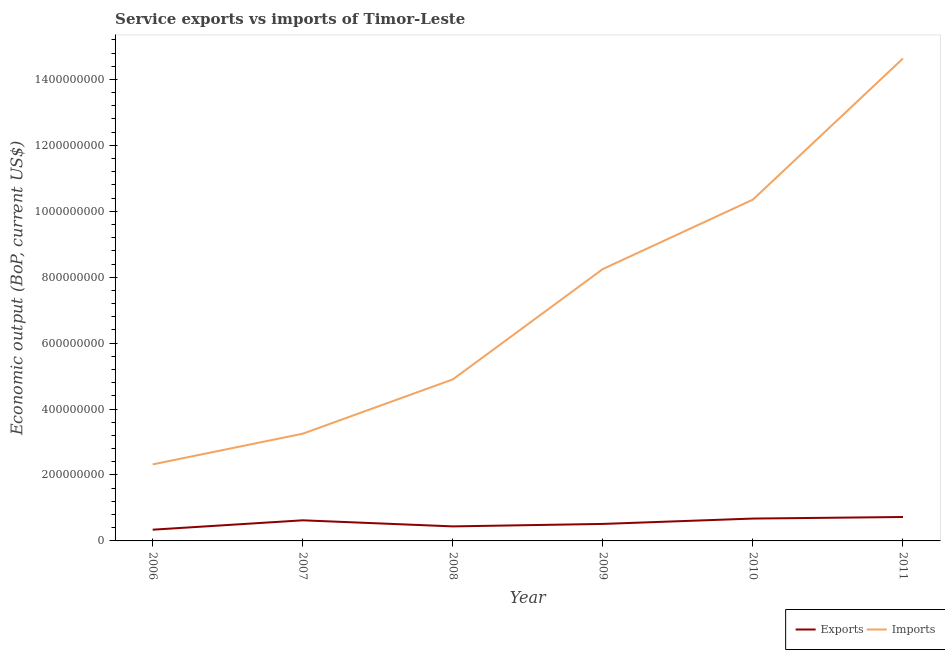How many different coloured lines are there?
Ensure brevity in your answer.  2. What is the amount of service imports in 2011?
Offer a very short reply. 1.46e+09. Across all years, what is the maximum amount of service imports?
Offer a very short reply. 1.46e+09. Across all years, what is the minimum amount of service imports?
Provide a short and direct response. 2.32e+08. In which year was the amount of service exports minimum?
Your answer should be very brief. 2006. What is the total amount of service imports in the graph?
Ensure brevity in your answer.  4.37e+09. What is the difference between the amount of service imports in 2006 and that in 2007?
Offer a very short reply. -9.31e+07. What is the difference between the amount of service exports in 2011 and the amount of service imports in 2009?
Keep it short and to the point. -7.52e+08. What is the average amount of service exports per year?
Your answer should be compact. 5.54e+07. In the year 2011, what is the difference between the amount of service exports and amount of service imports?
Keep it short and to the point. -1.39e+09. In how many years, is the amount of service imports greater than 920000000 US$?
Keep it short and to the point. 2. What is the ratio of the amount of service imports in 2007 to that in 2011?
Offer a very short reply. 0.22. Is the difference between the amount of service imports in 2006 and 2008 greater than the difference between the amount of service exports in 2006 and 2008?
Give a very brief answer. No. What is the difference between the highest and the second highest amount of service exports?
Offer a terse response. 4.77e+06. What is the difference between the highest and the lowest amount of service exports?
Provide a short and direct response. 3.85e+07. Is the amount of service imports strictly greater than the amount of service exports over the years?
Your response must be concise. Yes. Is the amount of service exports strictly less than the amount of service imports over the years?
Your response must be concise. Yes. How many lines are there?
Give a very brief answer. 2. What is the difference between two consecutive major ticks on the Y-axis?
Ensure brevity in your answer.  2.00e+08. Does the graph contain any zero values?
Keep it short and to the point. No. Does the graph contain grids?
Ensure brevity in your answer.  No. What is the title of the graph?
Your answer should be very brief. Service exports vs imports of Timor-Leste. Does "Sanitation services" appear as one of the legend labels in the graph?
Provide a succinct answer. No. What is the label or title of the Y-axis?
Give a very brief answer. Economic output (BoP, current US$). What is the Economic output (BoP, current US$) in Exports in 2006?
Make the answer very short. 3.41e+07. What is the Economic output (BoP, current US$) in Imports in 2006?
Give a very brief answer. 2.32e+08. What is the Economic output (BoP, current US$) in Exports in 2007?
Your response must be concise. 6.25e+07. What is the Economic output (BoP, current US$) in Imports in 2007?
Keep it short and to the point. 3.25e+08. What is the Economic output (BoP, current US$) of Exports in 2008?
Make the answer very short. 4.41e+07. What is the Economic output (BoP, current US$) in Imports in 2008?
Your answer should be very brief. 4.90e+08. What is the Economic output (BoP, current US$) of Exports in 2009?
Provide a succinct answer. 5.16e+07. What is the Economic output (BoP, current US$) in Imports in 2009?
Offer a terse response. 8.25e+08. What is the Economic output (BoP, current US$) of Exports in 2010?
Make the answer very short. 6.78e+07. What is the Economic output (BoP, current US$) in Imports in 2010?
Make the answer very short. 1.04e+09. What is the Economic output (BoP, current US$) in Exports in 2011?
Provide a succinct answer. 7.26e+07. What is the Economic output (BoP, current US$) of Imports in 2011?
Offer a very short reply. 1.46e+09. Across all years, what is the maximum Economic output (BoP, current US$) of Exports?
Provide a succinct answer. 7.26e+07. Across all years, what is the maximum Economic output (BoP, current US$) of Imports?
Your answer should be compact. 1.46e+09. Across all years, what is the minimum Economic output (BoP, current US$) in Exports?
Make the answer very short. 3.41e+07. Across all years, what is the minimum Economic output (BoP, current US$) of Imports?
Offer a very short reply. 2.32e+08. What is the total Economic output (BoP, current US$) of Exports in the graph?
Offer a terse response. 3.33e+08. What is the total Economic output (BoP, current US$) in Imports in the graph?
Give a very brief answer. 4.37e+09. What is the difference between the Economic output (BoP, current US$) of Exports in 2006 and that in 2007?
Provide a succinct answer. -2.84e+07. What is the difference between the Economic output (BoP, current US$) of Imports in 2006 and that in 2007?
Your response must be concise. -9.31e+07. What is the difference between the Economic output (BoP, current US$) of Exports in 2006 and that in 2008?
Ensure brevity in your answer.  -9.99e+06. What is the difference between the Economic output (BoP, current US$) in Imports in 2006 and that in 2008?
Offer a very short reply. -2.58e+08. What is the difference between the Economic output (BoP, current US$) in Exports in 2006 and that in 2009?
Keep it short and to the point. -1.75e+07. What is the difference between the Economic output (BoP, current US$) in Imports in 2006 and that in 2009?
Ensure brevity in your answer.  -5.93e+08. What is the difference between the Economic output (BoP, current US$) of Exports in 2006 and that in 2010?
Your answer should be very brief. -3.37e+07. What is the difference between the Economic output (BoP, current US$) of Imports in 2006 and that in 2010?
Provide a short and direct response. -8.03e+08. What is the difference between the Economic output (BoP, current US$) of Exports in 2006 and that in 2011?
Make the answer very short. -3.85e+07. What is the difference between the Economic output (BoP, current US$) of Imports in 2006 and that in 2011?
Offer a very short reply. -1.23e+09. What is the difference between the Economic output (BoP, current US$) in Exports in 2007 and that in 2008?
Ensure brevity in your answer.  1.84e+07. What is the difference between the Economic output (BoP, current US$) in Imports in 2007 and that in 2008?
Make the answer very short. -1.65e+08. What is the difference between the Economic output (BoP, current US$) in Exports in 2007 and that in 2009?
Keep it short and to the point. 1.10e+07. What is the difference between the Economic output (BoP, current US$) in Imports in 2007 and that in 2009?
Offer a terse response. -5.00e+08. What is the difference between the Economic output (BoP, current US$) of Exports in 2007 and that in 2010?
Offer a very short reply. -5.30e+06. What is the difference between the Economic output (BoP, current US$) in Imports in 2007 and that in 2010?
Provide a succinct answer. -7.10e+08. What is the difference between the Economic output (BoP, current US$) of Exports in 2007 and that in 2011?
Provide a succinct answer. -1.01e+07. What is the difference between the Economic output (BoP, current US$) in Imports in 2007 and that in 2011?
Give a very brief answer. -1.14e+09. What is the difference between the Economic output (BoP, current US$) of Exports in 2008 and that in 2009?
Your response must be concise. -7.47e+06. What is the difference between the Economic output (BoP, current US$) in Imports in 2008 and that in 2009?
Your response must be concise. -3.35e+08. What is the difference between the Economic output (BoP, current US$) of Exports in 2008 and that in 2010?
Make the answer very short. -2.37e+07. What is the difference between the Economic output (BoP, current US$) in Imports in 2008 and that in 2010?
Offer a very short reply. -5.45e+08. What is the difference between the Economic output (BoP, current US$) in Exports in 2008 and that in 2011?
Your answer should be compact. -2.85e+07. What is the difference between the Economic output (BoP, current US$) of Imports in 2008 and that in 2011?
Keep it short and to the point. -9.74e+08. What is the difference between the Economic output (BoP, current US$) in Exports in 2009 and that in 2010?
Your response must be concise. -1.63e+07. What is the difference between the Economic output (BoP, current US$) of Imports in 2009 and that in 2010?
Give a very brief answer. -2.11e+08. What is the difference between the Economic output (BoP, current US$) of Exports in 2009 and that in 2011?
Keep it short and to the point. -2.10e+07. What is the difference between the Economic output (BoP, current US$) in Imports in 2009 and that in 2011?
Give a very brief answer. -6.39e+08. What is the difference between the Economic output (BoP, current US$) in Exports in 2010 and that in 2011?
Provide a short and direct response. -4.77e+06. What is the difference between the Economic output (BoP, current US$) in Imports in 2010 and that in 2011?
Offer a very short reply. -4.28e+08. What is the difference between the Economic output (BoP, current US$) of Exports in 2006 and the Economic output (BoP, current US$) of Imports in 2007?
Give a very brief answer. -2.91e+08. What is the difference between the Economic output (BoP, current US$) of Exports in 2006 and the Economic output (BoP, current US$) of Imports in 2008?
Offer a very short reply. -4.56e+08. What is the difference between the Economic output (BoP, current US$) of Exports in 2006 and the Economic output (BoP, current US$) of Imports in 2009?
Provide a succinct answer. -7.91e+08. What is the difference between the Economic output (BoP, current US$) in Exports in 2006 and the Economic output (BoP, current US$) in Imports in 2010?
Your response must be concise. -1.00e+09. What is the difference between the Economic output (BoP, current US$) of Exports in 2006 and the Economic output (BoP, current US$) of Imports in 2011?
Keep it short and to the point. -1.43e+09. What is the difference between the Economic output (BoP, current US$) in Exports in 2007 and the Economic output (BoP, current US$) in Imports in 2008?
Offer a terse response. -4.27e+08. What is the difference between the Economic output (BoP, current US$) of Exports in 2007 and the Economic output (BoP, current US$) of Imports in 2009?
Ensure brevity in your answer.  -7.62e+08. What is the difference between the Economic output (BoP, current US$) in Exports in 2007 and the Economic output (BoP, current US$) in Imports in 2010?
Your answer should be very brief. -9.73e+08. What is the difference between the Economic output (BoP, current US$) in Exports in 2007 and the Economic output (BoP, current US$) in Imports in 2011?
Your answer should be compact. -1.40e+09. What is the difference between the Economic output (BoP, current US$) of Exports in 2008 and the Economic output (BoP, current US$) of Imports in 2009?
Provide a short and direct response. -7.81e+08. What is the difference between the Economic output (BoP, current US$) of Exports in 2008 and the Economic output (BoP, current US$) of Imports in 2010?
Give a very brief answer. -9.91e+08. What is the difference between the Economic output (BoP, current US$) of Exports in 2008 and the Economic output (BoP, current US$) of Imports in 2011?
Provide a succinct answer. -1.42e+09. What is the difference between the Economic output (BoP, current US$) in Exports in 2009 and the Economic output (BoP, current US$) in Imports in 2010?
Keep it short and to the point. -9.84e+08. What is the difference between the Economic output (BoP, current US$) in Exports in 2009 and the Economic output (BoP, current US$) in Imports in 2011?
Your response must be concise. -1.41e+09. What is the difference between the Economic output (BoP, current US$) in Exports in 2010 and the Economic output (BoP, current US$) in Imports in 2011?
Offer a terse response. -1.40e+09. What is the average Economic output (BoP, current US$) in Exports per year?
Provide a short and direct response. 5.54e+07. What is the average Economic output (BoP, current US$) in Imports per year?
Provide a succinct answer. 7.28e+08. In the year 2006, what is the difference between the Economic output (BoP, current US$) of Exports and Economic output (BoP, current US$) of Imports?
Your answer should be very brief. -1.98e+08. In the year 2007, what is the difference between the Economic output (BoP, current US$) of Exports and Economic output (BoP, current US$) of Imports?
Your answer should be very brief. -2.63e+08. In the year 2008, what is the difference between the Economic output (BoP, current US$) in Exports and Economic output (BoP, current US$) in Imports?
Give a very brief answer. -4.46e+08. In the year 2009, what is the difference between the Economic output (BoP, current US$) of Exports and Economic output (BoP, current US$) of Imports?
Offer a terse response. -7.73e+08. In the year 2010, what is the difference between the Economic output (BoP, current US$) in Exports and Economic output (BoP, current US$) in Imports?
Your answer should be very brief. -9.67e+08. In the year 2011, what is the difference between the Economic output (BoP, current US$) of Exports and Economic output (BoP, current US$) of Imports?
Provide a short and direct response. -1.39e+09. What is the ratio of the Economic output (BoP, current US$) of Exports in 2006 to that in 2007?
Your response must be concise. 0.55. What is the ratio of the Economic output (BoP, current US$) of Imports in 2006 to that in 2007?
Your response must be concise. 0.71. What is the ratio of the Economic output (BoP, current US$) in Exports in 2006 to that in 2008?
Offer a terse response. 0.77. What is the ratio of the Economic output (BoP, current US$) of Imports in 2006 to that in 2008?
Make the answer very short. 0.47. What is the ratio of the Economic output (BoP, current US$) of Exports in 2006 to that in 2009?
Your answer should be very brief. 0.66. What is the ratio of the Economic output (BoP, current US$) in Imports in 2006 to that in 2009?
Provide a succinct answer. 0.28. What is the ratio of the Economic output (BoP, current US$) in Exports in 2006 to that in 2010?
Give a very brief answer. 0.5. What is the ratio of the Economic output (BoP, current US$) in Imports in 2006 to that in 2010?
Your answer should be very brief. 0.22. What is the ratio of the Economic output (BoP, current US$) of Exports in 2006 to that in 2011?
Your answer should be very brief. 0.47. What is the ratio of the Economic output (BoP, current US$) of Imports in 2006 to that in 2011?
Keep it short and to the point. 0.16. What is the ratio of the Economic output (BoP, current US$) in Exports in 2007 to that in 2008?
Offer a very short reply. 1.42. What is the ratio of the Economic output (BoP, current US$) in Imports in 2007 to that in 2008?
Make the answer very short. 0.66. What is the ratio of the Economic output (BoP, current US$) in Exports in 2007 to that in 2009?
Your response must be concise. 1.21. What is the ratio of the Economic output (BoP, current US$) in Imports in 2007 to that in 2009?
Provide a short and direct response. 0.39. What is the ratio of the Economic output (BoP, current US$) in Exports in 2007 to that in 2010?
Provide a succinct answer. 0.92. What is the ratio of the Economic output (BoP, current US$) of Imports in 2007 to that in 2010?
Keep it short and to the point. 0.31. What is the ratio of the Economic output (BoP, current US$) in Exports in 2007 to that in 2011?
Give a very brief answer. 0.86. What is the ratio of the Economic output (BoP, current US$) of Imports in 2007 to that in 2011?
Offer a very short reply. 0.22. What is the ratio of the Economic output (BoP, current US$) of Exports in 2008 to that in 2009?
Provide a short and direct response. 0.86. What is the ratio of the Economic output (BoP, current US$) of Imports in 2008 to that in 2009?
Make the answer very short. 0.59. What is the ratio of the Economic output (BoP, current US$) in Exports in 2008 to that in 2010?
Make the answer very short. 0.65. What is the ratio of the Economic output (BoP, current US$) of Imports in 2008 to that in 2010?
Provide a succinct answer. 0.47. What is the ratio of the Economic output (BoP, current US$) in Exports in 2008 to that in 2011?
Provide a succinct answer. 0.61. What is the ratio of the Economic output (BoP, current US$) of Imports in 2008 to that in 2011?
Provide a short and direct response. 0.33. What is the ratio of the Economic output (BoP, current US$) in Exports in 2009 to that in 2010?
Provide a short and direct response. 0.76. What is the ratio of the Economic output (BoP, current US$) of Imports in 2009 to that in 2010?
Provide a short and direct response. 0.8. What is the ratio of the Economic output (BoP, current US$) in Exports in 2009 to that in 2011?
Offer a very short reply. 0.71. What is the ratio of the Economic output (BoP, current US$) in Imports in 2009 to that in 2011?
Offer a very short reply. 0.56. What is the ratio of the Economic output (BoP, current US$) of Exports in 2010 to that in 2011?
Your answer should be compact. 0.93. What is the ratio of the Economic output (BoP, current US$) in Imports in 2010 to that in 2011?
Your response must be concise. 0.71. What is the difference between the highest and the second highest Economic output (BoP, current US$) of Exports?
Ensure brevity in your answer.  4.77e+06. What is the difference between the highest and the second highest Economic output (BoP, current US$) in Imports?
Give a very brief answer. 4.28e+08. What is the difference between the highest and the lowest Economic output (BoP, current US$) in Exports?
Ensure brevity in your answer.  3.85e+07. What is the difference between the highest and the lowest Economic output (BoP, current US$) of Imports?
Your answer should be very brief. 1.23e+09. 